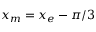<formula> <loc_0><loc_0><loc_500><loc_500>x _ { m } = x _ { e } - \pi / 3</formula> 